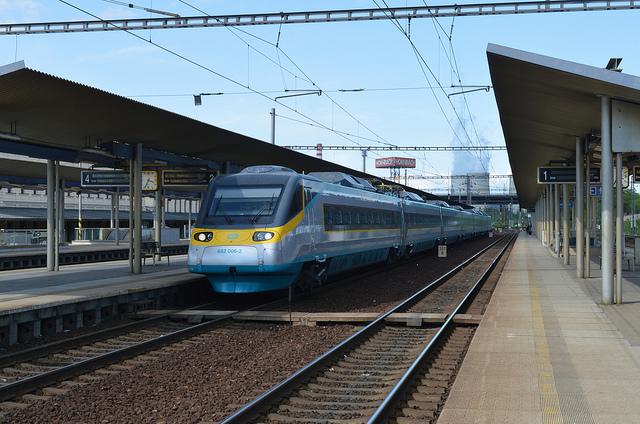Are there any people on the platform?
Answer briefly. No. Is the train stopped?
Keep it brief. Yes. How many sets of tracks are there?
Keep it brief. 2. How many tracks can be seen?
Short answer required. 2. How many trains are there?
Concise answer only. 1. 